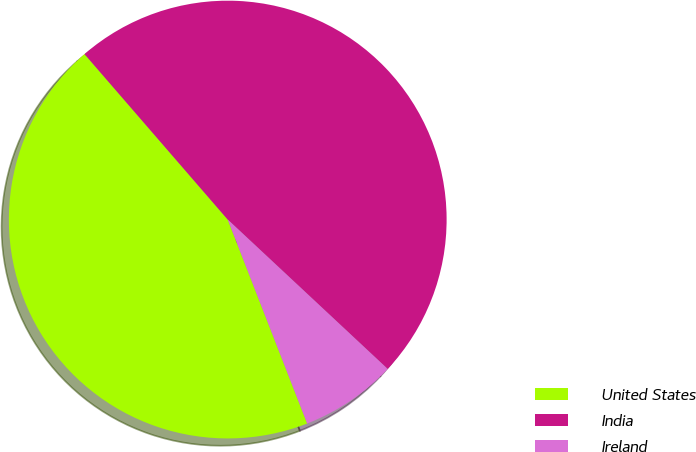Convert chart to OTSL. <chart><loc_0><loc_0><loc_500><loc_500><pie_chart><fcel>United States<fcel>India<fcel>Ireland<nl><fcel>44.56%<fcel>48.31%<fcel>7.13%<nl></chart> 